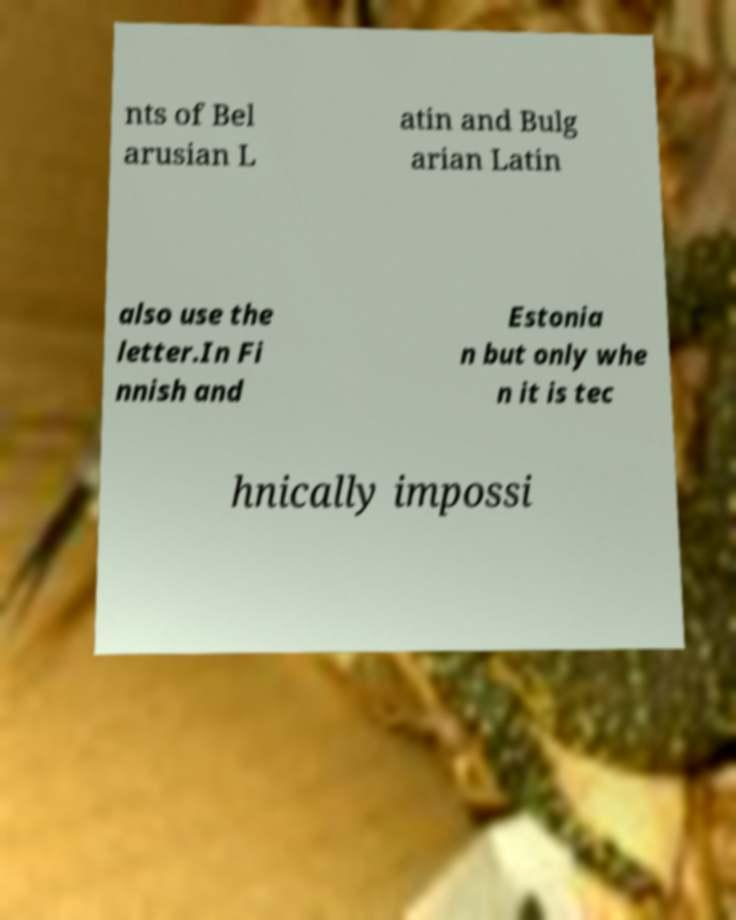I need the written content from this picture converted into text. Can you do that? nts of Bel arusian L atin and Bulg arian Latin also use the letter.In Fi nnish and Estonia n but only whe n it is tec hnically impossi 